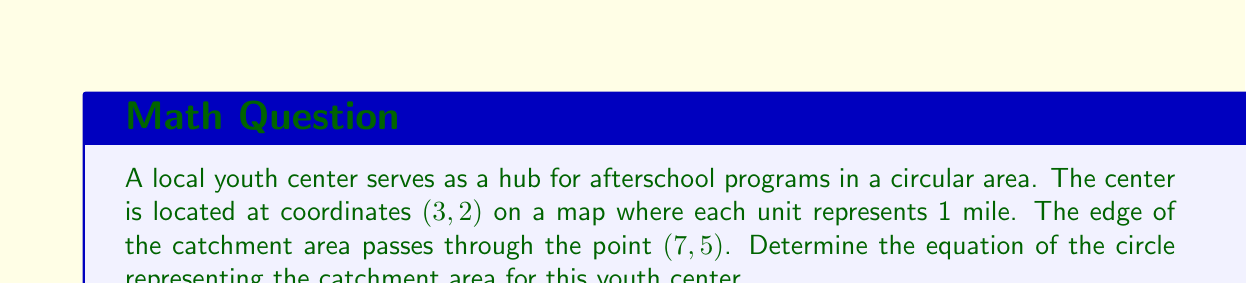Give your solution to this math problem. To find the equation of the circle, we need to determine its center and radius. Let's approach this step-by-step:

1. The general equation of a circle is:
   $$(x - h)^2 + (y - k)^2 = r^2$$
   where $(h, k)$ is the center and $r$ is the radius.

2. We're given that the center of the circle (the youth center's location) is at (3, 2), so $h = 3$ and $k = 2$.

3. To find the radius, we need to calculate the distance between the center (3, 2) and a point on the circle (7, 5). We can use the distance formula:

   $$r = \sqrt{(x_2 - x_1)^2 + (y_2 - y_1)^2}$$
   $$r = \sqrt{(7 - 3)^2 + (5 - 2)^2}$$
   $$r = \sqrt{4^2 + 3^2}$$
   $$r = \sqrt{16 + 9}$$
   $$r = \sqrt{25}$$
   $$r = 5$$

4. Now that we have the center (3, 2) and the radius (5), we can substitute these into the general equation:

   $$(x - 3)^2 + (y - 2)^2 = 5^2$$

5. Simplify by squaring the right side:

   $$(x - 3)^2 + (y - 2)^2 = 25$$

This is the equation of the circle representing the catchment area for the youth center.
Answer: $$(x - 3)^2 + (y - 2)^2 = 25$$ 